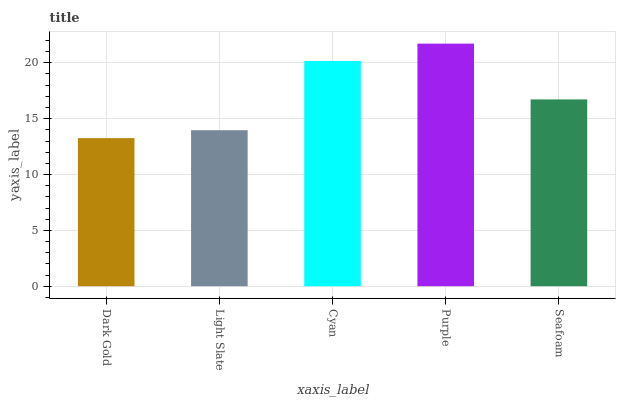Is Dark Gold the minimum?
Answer yes or no. Yes. Is Purple the maximum?
Answer yes or no. Yes. Is Light Slate the minimum?
Answer yes or no. No. Is Light Slate the maximum?
Answer yes or no. No. Is Light Slate greater than Dark Gold?
Answer yes or no. Yes. Is Dark Gold less than Light Slate?
Answer yes or no. Yes. Is Dark Gold greater than Light Slate?
Answer yes or no. No. Is Light Slate less than Dark Gold?
Answer yes or no. No. Is Seafoam the high median?
Answer yes or no. Yes. Is Seafoam the low median?
Answer yes or no. Yes. Is Cyan the high median?
Answer yes or no. No. Is Cyan the low median?
Answer yes or no. No. 